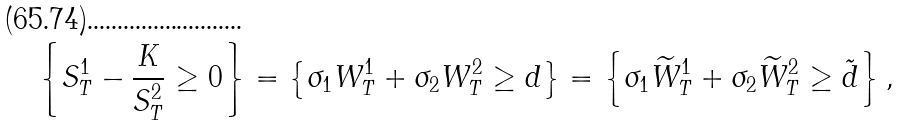Convert formula to latex. <formula><loc_0><loc_0><loc_500><loc_500>\left \{ S ^ { 1 } _ { T } - \frac { K } { S ^ { 2 } _ { T } } \geq 0 \right \} = \left \{ \sigma _ { 1 } W ^ { 1 } _ { T } + \sigma _ { 2 } W ^ { 2 } _ { T } \geq d \right \} = \left \{ \sigma _ { 1 } \widetilde { W } ^ { 1 } _ { T } + \sigma _ { 2 } \widetilde { W } ^ { 2 } _ { T } \geq \tilde { d } \right \} ,</formula> 